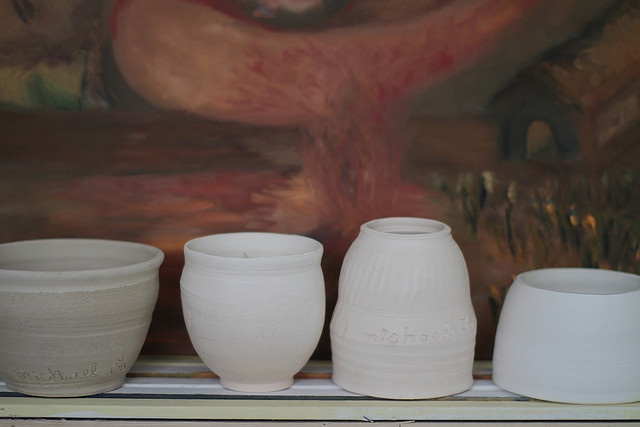Describe the objects in this image and their specific colors. I can see cup in maroon, darkgray, gray, and black tones, cup in maroon and gray tones, vase in maroon, darkgray, and gray tones, bowl in maroon and gray tones, and vase in maroon and gray tones in this image. 